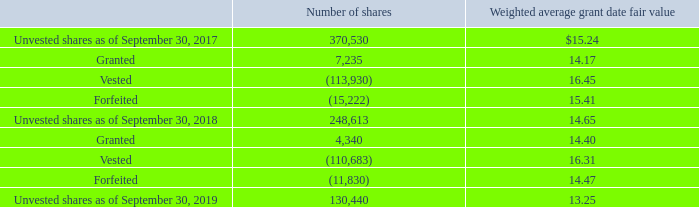Restricted Stock: The Company’s 2007 Stock Compensation Plan permits our Compensation Committee to grant other stock-based awards. The Company has awarded restricted stock grants to employees that vest over one to ten years.
The Company repurchased a total of 40,933 shares of our common stock at an average price of $13.51 in connection with payment of taxes upon the vesting of restricted stock previously issued to employees for the year ended September 30, 2019. The Company repurchased a total of 41,989 shares of our common stock at an average price of $11.66 in connection with payment of taxes upon the vesting of restricted stock previously issued to employees for the year ended September 30, 2018.
Employee Stock Purchase Plan: The Clearfield, Inc. 2010 Employee Stock Purchase Plan (“ESPP”) allows participating employees to purchase shares of the Company’s common stock at a discount through payroll deductions. The ESPP is available to all employees subject to certain eligibility requirements. Terms of the ESPP provide that participating employees may purchase the Company’s common stock on a voluntary after tax basis. Employees may purchase the Company’s common stock at a price that is no less than the lower of 85% of the fair market value of one share of common stock at the beginning or end of each stock purchase period or phase. The ESPP is carried out in six-month phases, with phases beginning on July 1 and January 1 of each calendar year. For the phases that ended on December 31, 2018 and June 30, 2019, employees purchased 17,312 and 19,923 shares, respectively, at a price of $8.43. For the phases that ended on December 31, 2017 and June 30, 2018, employees purchased 14,242 and 15,932 shares, respectively, at a price of $10.41 and $9.39 per share, respectively. As of September 30, 2019, the Company has withheld approximately $80,708 from employees participating in the phase that began on July 1, 2019. After the employee purchase on June 30, 2019, 49,846 shares of common stock were available for future purchase under the ESPP. Employee Stock Purchase Plan: The Clearfield, Inc. 2010 Employee Stock Purchase Plan (“ESPP”) allows participating employees to purchase shares of the Company’s common stock at a discount through payroll deductions. The ESPP is available to all employees subject to certain eligibility requirements. Terms of the ESPP provide that participating employees may purchase the Company’s common stock on a voluntary after tax basis. Employees may purchase the Company’s common stock at a price that is no less than the lower of 85% of the fair market value of one share of common stock at the beginning or end of each stock purchase period or phase. The ESPP is carried out in six-month phases, with phases beginning on July 1 and January 1 of each calendar year. For the phases that ended on December 31, 2018 and June 30, 2019, employees purchased 17,312 and 19,923 shares, respectively, at a price of $8.43. For the phases that ended on December 31, 2017 and June 30, 2018, employees purchased 14,242 and 15,932 shares, respectively, at a price of $10.41 and $9.39 per share, respectively. As of September 30, 2019, the Company has withheld approximately $80,708 from employees participating in the phase that began on July 1, 2019. After the employee purchase on June 30, 2019, 49,846 shares of common stock were available for future purchase under the ESPP.
Restricted stock transactions during the years ended September 30, 2019 and 2018 are summarized as follows:
What is the total repurchased shares of common stock for the year ended September 30, 2019? 40,933. What is the total number of unvested shares as of September 30, 2019? 130,440. What is the use of the Clearfield, Inc. 2010 Employee Stock Purchase Plan? Allows participating employees to purchase shares of the company’s common stock at a discount through payroll deductions. What is the total value of shares purchased for the ESPP phase ended December 31, 2018? 17,312*8.43
Answer: 145940.16. What is the total value of repurchased stock for the year ended September 30, 2019? 40,933*13.51
Answer: 553004.83. What is the percentage change in the total value of shares purchased by employees from 30 June 2018 to 30 June 2019?
Answer scale should be: percent. ((19,923*8.43)-(15,932*9.39))/(15,932*9.39)
Answer: 12.27. 